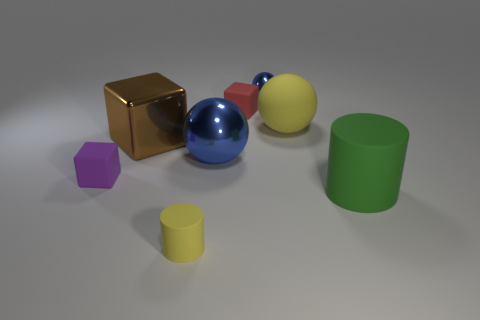What number of large green things have the same material as the tiny red object?
Offer a very short reply. 1. There is a blue ball that is on the left side of the small rubber cube that is right of the large brown shiny object; what is its size?
Provide a succinct answer. Large. The rubber thing that is both to the right of the red thing and in front of the small purple block is what color?
Keep it short and to the point. Green. Do the large yellow thing and the green object have the same shape?
Provide a succinct answer. No. There is a ball that is the same color as the small cylinder; what size is it?
Your answer should be very brief. Large. There is a big thing that is to the left of the blue ball left of the small metallic sphere; what shape is it?
Ensure brevity in your answer.  Cube. There is a purple matte object; is its shape the same as the tiny matte thing behind the yellow rubber ball?
Provide a short and direct response. Yes. What is the color of the shiny ball that is the same size as the green cylinder?
Your answer should be compact. Blue. Is the number of tiny yellow matte cylinders on the left side of the small purple matte object less than the number of large objects that are on the right side of the yellow rubber cylinder?
Keep it short and to the point. Yes. There is a yellow thing on the right side of the small cube that is behind the block on the left side of the big metal cube; what shape is it?
Provide a succinct answer. Sphere. 